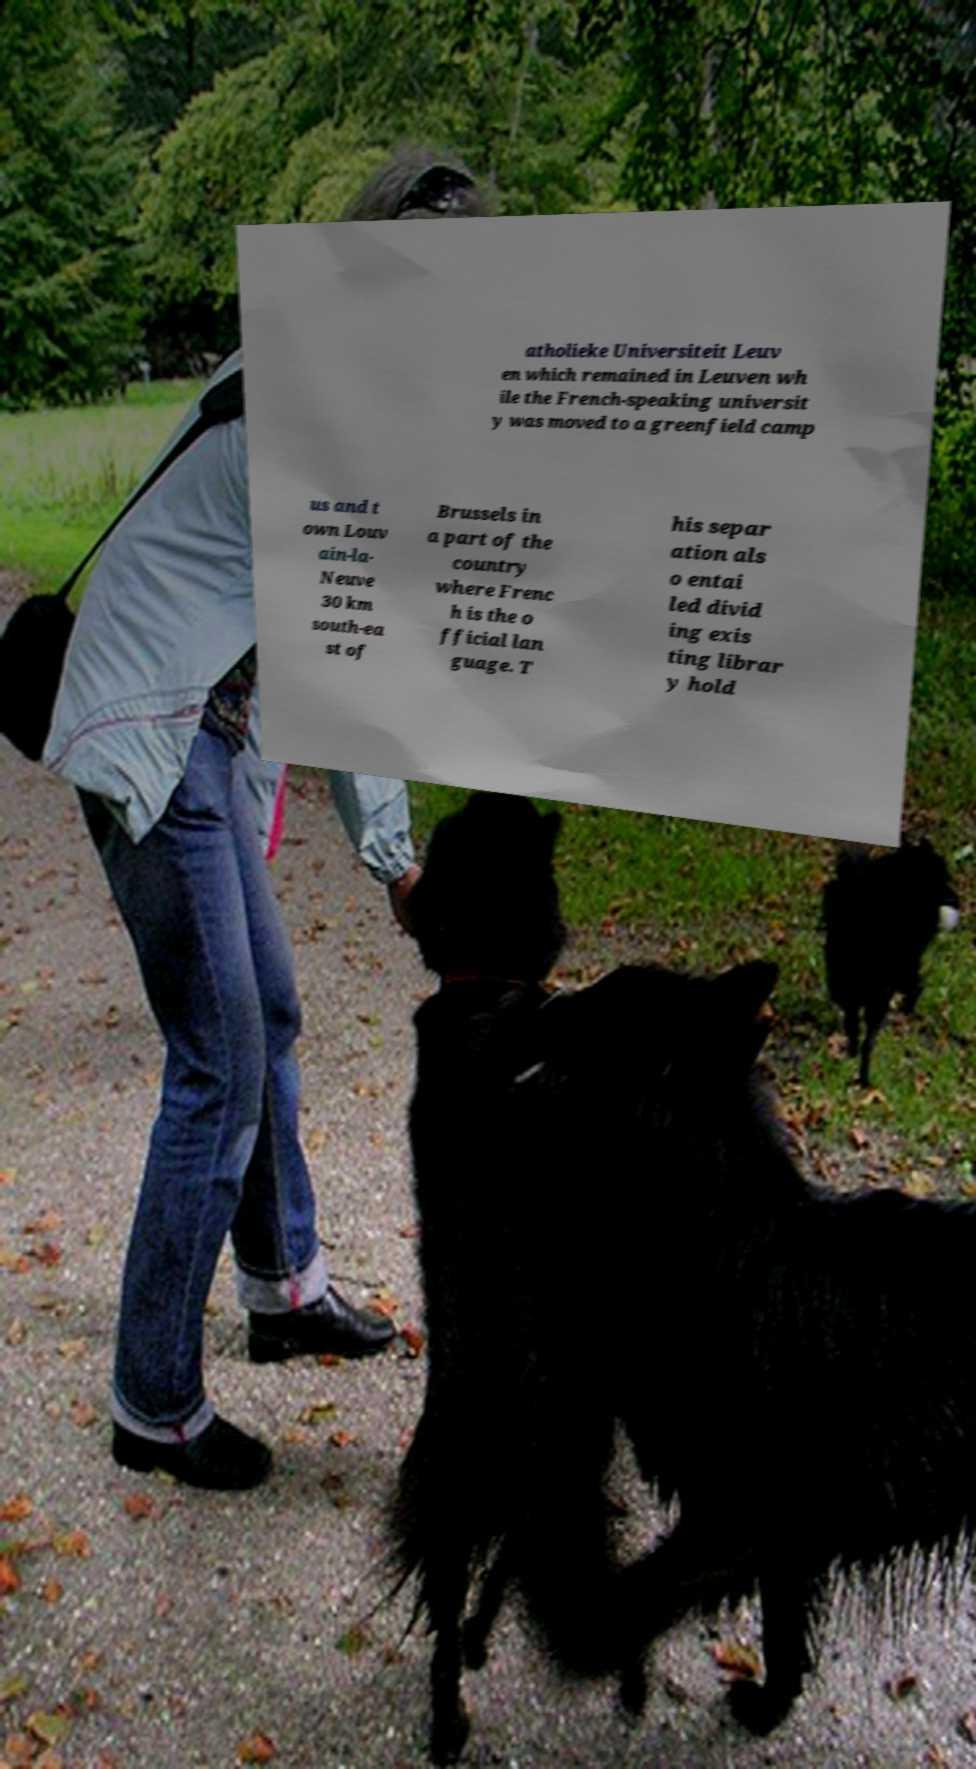Could you extract and type out the text from this image? atholieke Universiteit Leuv en which remained in Leuven wh ile the French-speaking universit y was moved to a greenfield camp us and t own Louv ain-la- Neuve 30 km south-ea st of Brussels in a part of the country where Frenc h is the o fficial lan guage. T his separ ation als o entai led divid ing exis ting librar y hold 